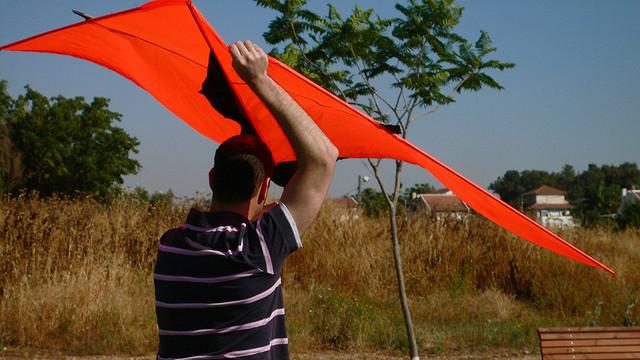Is anyone on the bench?
Concise answer only. No. What color is the object the man is carrying?
Answer briefly. Orange. Where is the man?
Short answer required. Park. What color is the kite?
Answer briefly. Orange. 